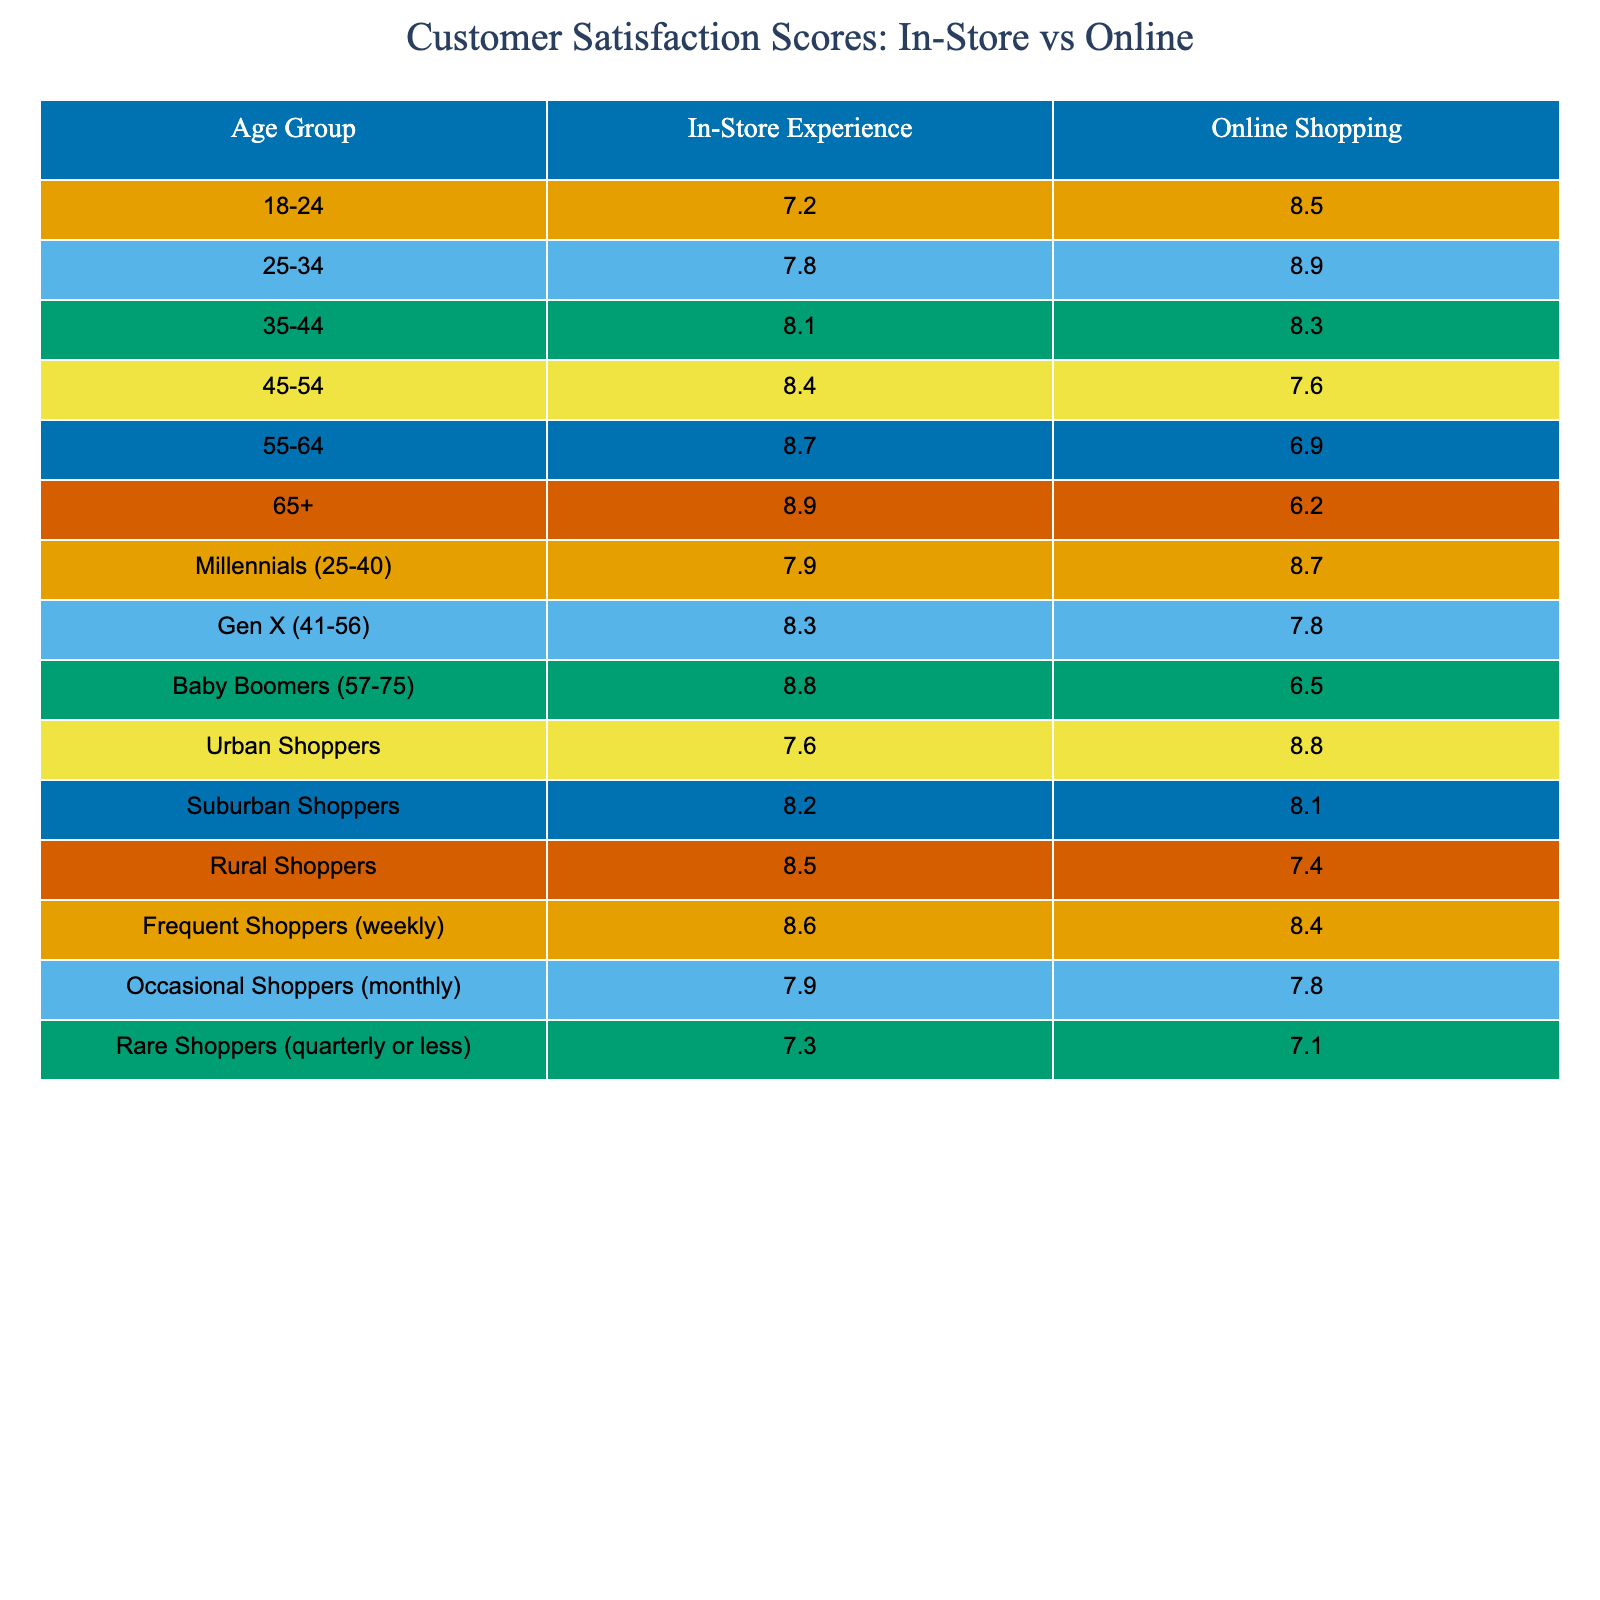What is the customer satisfaction score for the 18-24 age group in-store experience? The table shows the in-store experience score for the 18-24 age group as 7.2.
Answer: 7.2 How does the online shopping score for the 25-34 age group compare to the in-store score? The online shopping score for the 25-34 age group is 8.9, while the in-store score is 7.8. The online score is higher by 1.1 points.
Answer: Online score is higher by 1.1 points What is the satisfaction score for Baby Boomers when shopping online? According to the table, Baby Boomers have an online shopping score of 6.5.
Answer: 6.5 Which age group shows the highest satisfaction with the in-store experience? The 65+ age group has the highest in-store experience score of 8.9 in the table.
Answer: 8.9 What is the average in-store satisfaction score for all shoppers listed? The in-store scores for all age groups add up to: 7.2 + 7.8 + 8.1 + 8.4 + 8.7 + 8.9 + 7.9 + 8.3 + 8.8 + 7.6 + 8.2 + 8.5 + 8.6 + 7.9 + 7.3 = 128.6. There are 15 age groups, so the average is 128.6 / 15 = 8.5733, which rounds to approximately 8.57.
Answer: 8.57 Is the in-store experience score for Millennials higher than that for Urban Shoppers? Millennials have an in-store score of 7.9, while Urban Shoppers have a score of 7.6. Since 7.9 is greater than 7.6, the statement is true.
Answer: Yes If you compare the average online shopping scores for Frequent Shoppers and Rare Shoppers, which group has a higher average? Frequent Shoppers have an online score of 8.4, and Rare Shoppers have an online score of 7.1. Frequent Shoppers have the higher score.
Answer: Frequent Shoppers What is the difference between the maximum in-store score and the minimum in-store score across all age groups? The maximum in-store score is 8.9 (for 65+), and the minimum is 7.2 (for 18-24). The difference is 8.9 - 7.2 = 1.7.
Answer: 1.7 Are online shopping scores for those aged 55-64 lower than those for Millennials (25-40)? The online score for 55-64 is 6.9, and for Millennials, it's 8.7. Since 6.9 is less than 8.7, the statement is true.
Answer: Yes Which age range shows the greatest divergence between in-store and online shopping satisfaction scores? The greatest divergence can be determined by finding the difference for each age group. The largest difference is for the 55-64 age group (8.7 in-store vs. 6.9 online), which is a difference of 1.8 points.
Answer: 1.8 (for 55-64 age group) 